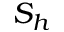<formula> <loc_0><loc_0><loc_500><loc_500>S _ { h }</formula> 